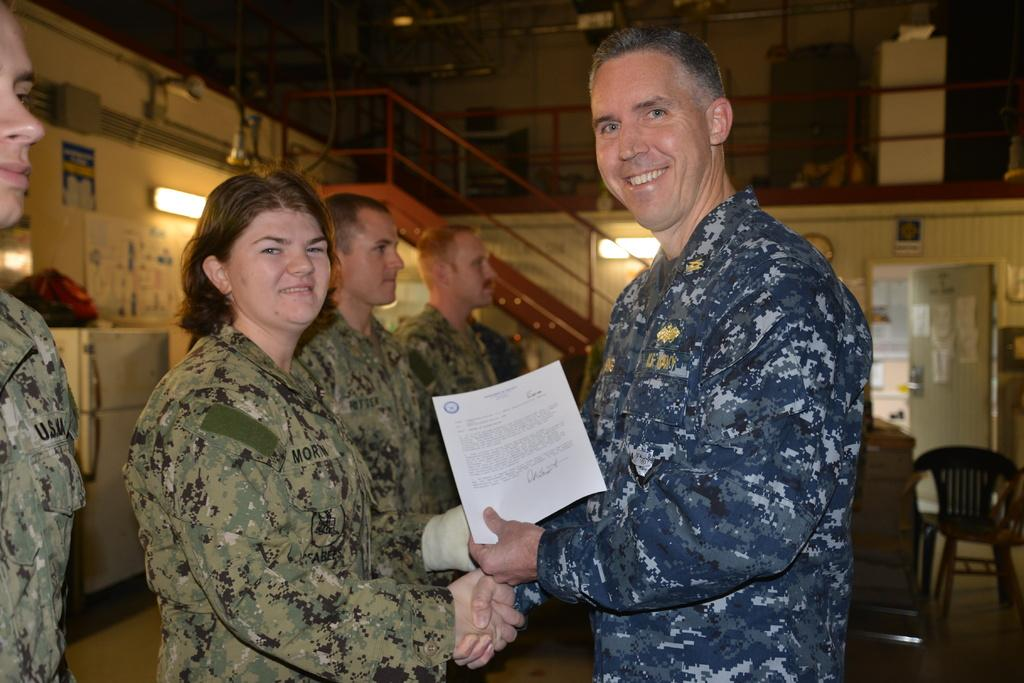What is happening with the people in the image? There are people standing in the image. Can you describe the expression of one of the individuals? A man is smiling in the image. What is the man holding in the image? The man is holding a paper. What objects can be seen in the background of the image? There is a chair and a refrigerator in the background of the image. What type of chicken is being used to clean the straw in the image? There is no chicken or straw present in the image. 